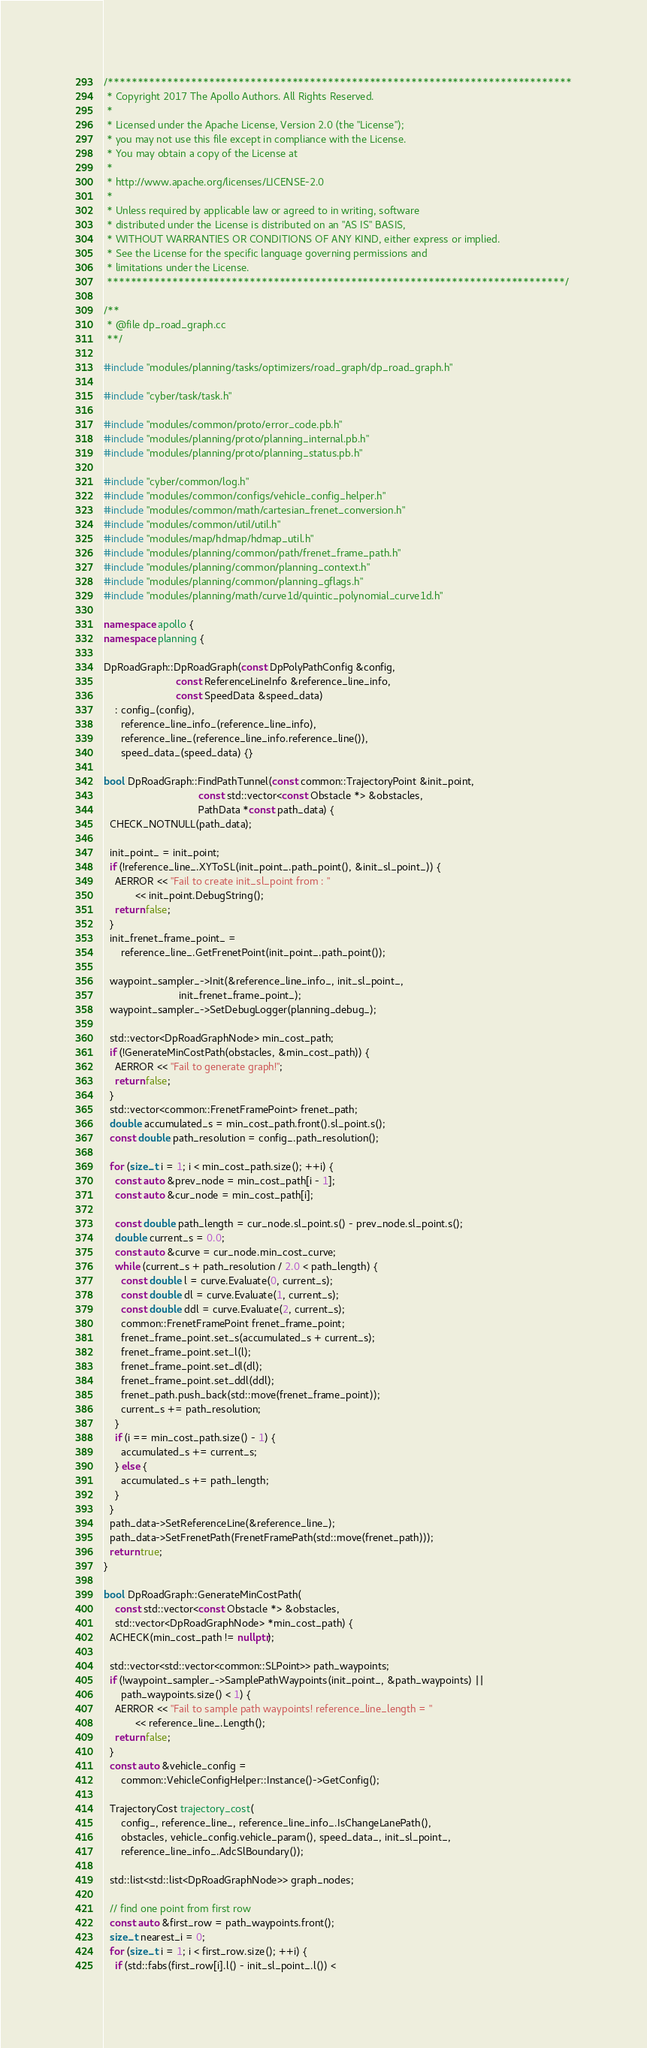Convert code to text. <code><loc_0><loc_0><loc_500><loc_500><_C++_>/******************************************************************************
 * Copyright 2017 The Apollo Authors. All Rights Reserved.
 *
 * Licensed under the Apache License, Version 2.0 (the "License");
 * you may not use this file except in compliance with the License.
 * You may obtain a copy of the License at
 *
 * http://www.apache.org/licenses/LICENSE-2.0
 *
 * Unless required by applicable law or agreed to in writing, software
 * distributed under the License is distributed on an "AS IS" BASIS,
 * WITHOUT WARRANTIES OR CONDITIONS OF ANY KIND, either express or implied.
 * See the License for the specific language governing permissions and
 * limitations under the License.
 *****************************************************************************/

/**
 * @file dp_road_graph.cc
 **/

#include "modules/planning/tasks/optimizers/road_graph/dp_road_graph.h"

#include "cyber/task/task.h"

#include "modules/common/proto/error_code.pb.h"
#include "modules/planning/proto/planning_internal.pb.h"
#include "modules/planning/proto/planning_status.pb.h"

#include "cyber/common/log.h"
#include "modules/common/configs/vehicle_config_helper.h"
#include "modules/common/math/cartesian_frenet_conversion.h"
#include "modules/common/util/util.h"
#include "modules/map/hdmap/hdmap_util.h"
#include "modules/planning/common/path/frenet_frame_path.h"
#include "modules/planning/common/planning_context.h"
#include "modules/planning/common/planning_gflags.h"
#include "modules/planning/math/curve1d/quintic_polynomial_curve1d.h"

namespace apollo {
namespace planning {

DpRoadGraph::DpRoadGraph(const DpPolyPathConfig &config,
                         const ReferenceLineInfo &reference_line_info,
                         const SpeedData &speed_data)
    : config_(config),
      reference_line_info_(reference_line_info),
      reference_line_(reference_line_info.reference_line()),
      speed_data_(speed_data) {}

bool DpRoadGraph::FindPathTunnel(const common::TrajectoryPoint &init_point,
                                 const std::vector<const Obstacle *> &obstacles,
                                 PathData *const path_data) {
  CHECK_NOTNULL(path_data);

  init_point_ = init_point;
  if (!reference_line_.XYToSL(init_point_.path_point(), &init_sl_point_)) {
    AERROR << "Fail to create init_sl_point from : "
           << init_point.DebugString();
    return false;
  }
  init_frenet_frame_point_ =
      reference_line_.GetFrenetPoint(init_point_.path_point());

  waypoint_sampler_->Init(&reference_line_info_, init_sl_point_,
                          init_frenet_frame_point_);
  waypoint_sampler_->SetDebugLogger(planning_debug_);

  std::vector<DpRoadGraphNode> min_cost_path;
  if (!GenerateMinCostPath(obstacles, &min_cost_path)) {
    AERROR << "Fail to generate graph!";
    return false;
  }
  std::vector<common::FrenetFramePoint> frenet_path;
  double accumulated_s = min_cost_path.front().sl_point.s();
  const double path_resolution = config_.path_resolution();

  for (size_t i = 1; i < min_cost_path.size(); ++i) {
    const auto &prev_node = min_cost_path[i - 1];
    const auto &cur_node = min_cost_path[i];

    const double path_length = cur_node.sl_point.s() - prev_node.sl_point.s();
    double current_s = 0.0;
    const auto &curve = cur_node.min_cost_curve;
    while (current_s + path_resolution / 2.0 < path_length) {
      const double l = curve.Evaluate(0, current_s);
      const double dl = curve.Evaluate(1, current_s);
      const double ddl = curve.Evaluate(2, current_s);
      common::FrenetFramePoint frenet_frame_point;
      frenet_frame_point.set_s(accumulated_s + current_s);
      frenet_frame_point.set_l(l);
      frenet_frame_point.set_dl(dl);
      frenet_frame_point.set_ddl(ddl);
      frenet_path.push_back(std::move(frenet_frame_point));
      current_s += path_resolution;
    }
    if (i == min_cost_path.size() - 1) {
      accumulated_s += current_s;
    } else {
      accumulated_s += path_length;
    }
  }
  path_data->SetReferenceLine(&reference_line_);
  path_data->SetFrenetPath(FrenetFramePath(std::move(frenet_path)));
  return true;
}

bool DpRoadGraph::GenerateMinCostPath(
    const std::vector<const Obstacle *> &obstacles,
    std::vector<DpRoadGraphNode> *min_cost_path) {
  ACHECK(min_cost_path != nullptr);

  std::vector<std::vector<common::SLPoint>> path_waypoints;
  if (!waypoint_sampler_->SamplePathWaypoints(init_point_, &path_waypoints) ||
      path_waypoints.size() < 1) {
    AERROR << "Fail to sample path waypoints! reference_line_length = "
           << reference_line_.Length();
    return false;
  }
  const auto &vehicle_config =
      common::VehicleConfigHelper::Instance()->GetConfig();

  TrajectoryCost trajectory_cost(
      config_, reference_line_, reference_line_info_.IsChangeLanePath(),
      obstacles, vehicle_config.vehicle_param(), speed_data_, init_sl_point_,
      reference_line_info_.AdcSlBoundary());

  std::list<std::list<DpRoadGraphNode>> graph_nodes;

  // find one point from first row
  const auto &first_row = path_waypoints.front();
  size_t nearest_i = 0;
  for (size_t i = 1; i < first_row.size(); ++i) {
    if (std::fabs(first_row[i].l() - init_sl_point_.l()) <</code> 